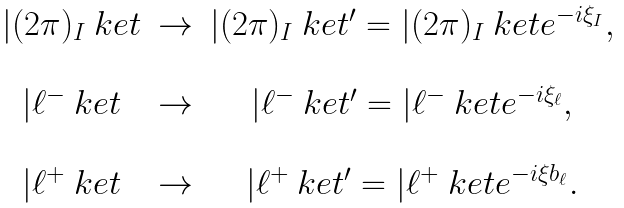<formula> <loc_0><loc_0><loc_500><loc_500>\begin{array} { c c c } | ( 2 \pi ) _ { I } \ k e t & \to & | ( 2 \pi ) _ { I } \ k e t ^ { \prime } = | ( 2 \pi ) _ { I } \ k e t e ^ { - i \xi _ { I } } , \\ \\ | \ell ^ { - } \ k e t & \to & | \ell ^ { - } \ k e t ^ { \prime } = | \ell ^ { - } \ k e t e ^ { - i \xi _ { \ell } } , \\ \\ | \ell ^ { + } \ k e t & \to & | \ell ^ { + } \ k e t ^ { \prime } = | \ell ^ { + } \ k e t e ^ { - i \xi b _ { \ell } } . \end{array}</formula> 